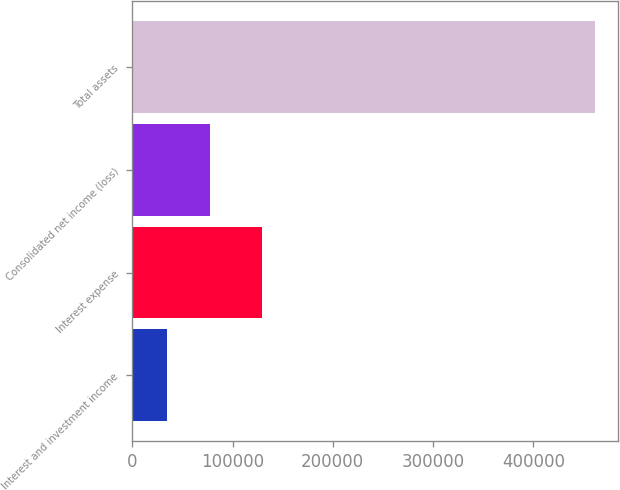Convert chart to OTSL. <chart><loc_0><loc_0><loc_500><loc_500><bar_chart><fcel>Interest and investment income<fcel>Interest expense<fcel>Consolidated net income (loss)<fcel>Total assets<nl><fcel>34303<fcel>129750<fcel>77023.2<fcel>461505<nl></chart> 